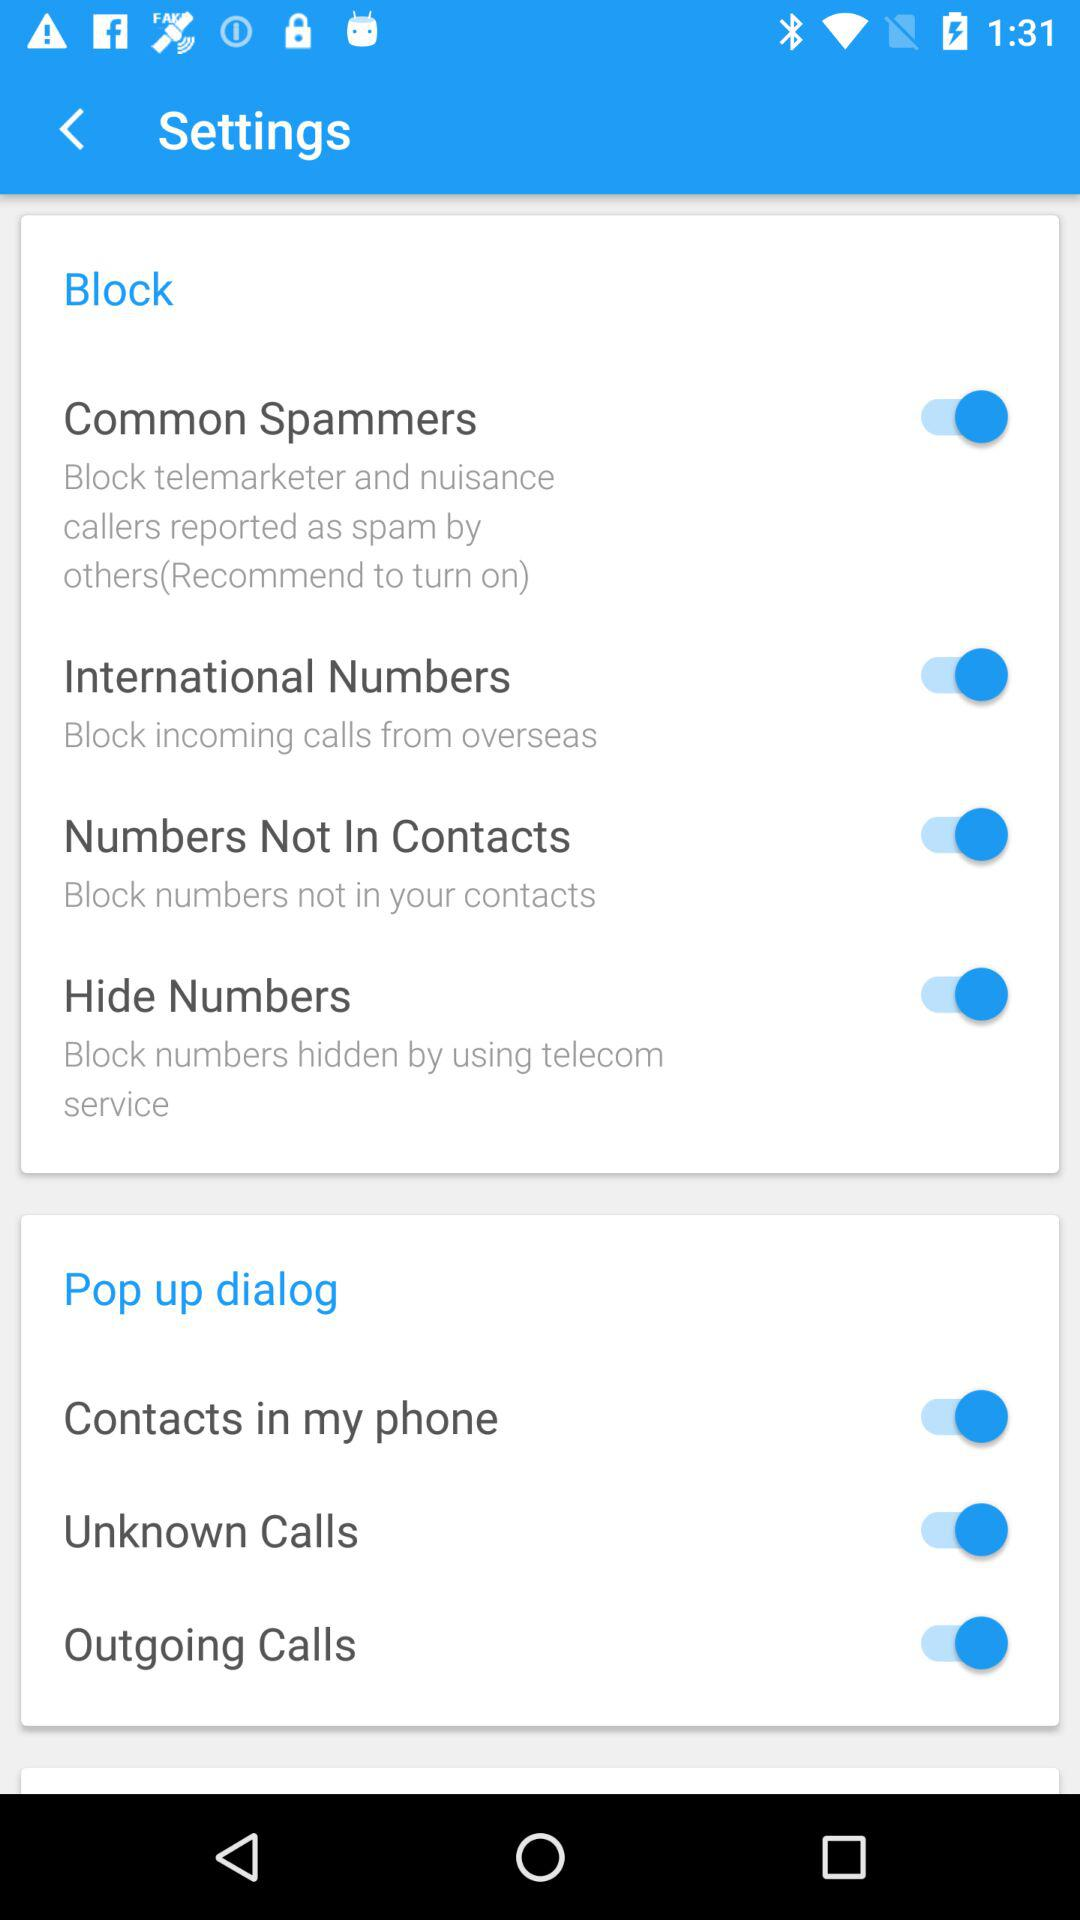Which options are listed under the "Pop up dialog" setting? The options that are listed under the "Pop up dialog" setting are "Contacts in my phone", "Unknown Calls" and "Outgoing Calls". 